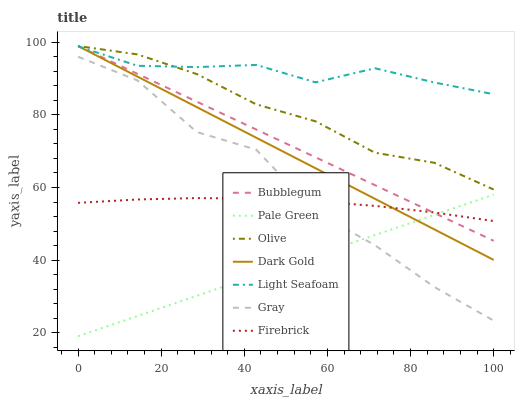Does Pale Green have the minimum area under the curve?
Answer yes or no. Yes. Does Light Seafoam have the maximum area under the curve?
Answer yes or no. Yes. Does Dark Gold have the minimum area under the curve?
Answer yes or no. No. Does Dark Gold have the maximum area under the curve?
Answer yes or no. No. Is Bubblegum the smoothest?
Answer yes or no. Yes. Is Gray the roughest?
Answer yes or no. Yes. Is Dark Gold the smoothest?
Answer yes or no. No. Is Dark Gold the roughest?
Answer yes or no. No. Does Pale Green have the lowest value?
Answer yes or no. Yes. Does Dark Gold have the lowest value?
Answer yes or no. No. Does Olive have the highest value?
Answer yes or no. Yes. Does Firebrick have the highest value?
Answer yes or no. No. Is Gray less than Bubblegum?
Answer yes or no. Yes. Is Olive greater than Gray?
Answer yes or no. Yes. Does Olive intersect Bubblegum?
Answer yes or no. Yes. Is Olive less than Bubblegum?
Answer yes or no. No. Is Olive greater than Bubblegum?
Answer yes or no. No. Does Gray intersect Bubblegum?
Answer yes or no. No. 